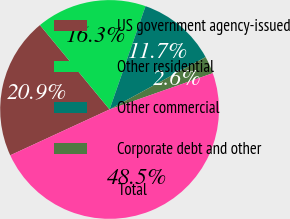Convert chart to OTSL. <chart><loc_0><loc_0><loc_500><loc_500><pie_chart><fcel>US government agency-issued<fcel>Other residential<fcel>Other commercial<fcel>Corporate debt and other<fcel>Total<nl><fcel>20.9%<fcel>16.31%<fcel>11.72%<fcel>2.57%<fcel>48.5%<nl></chart> 